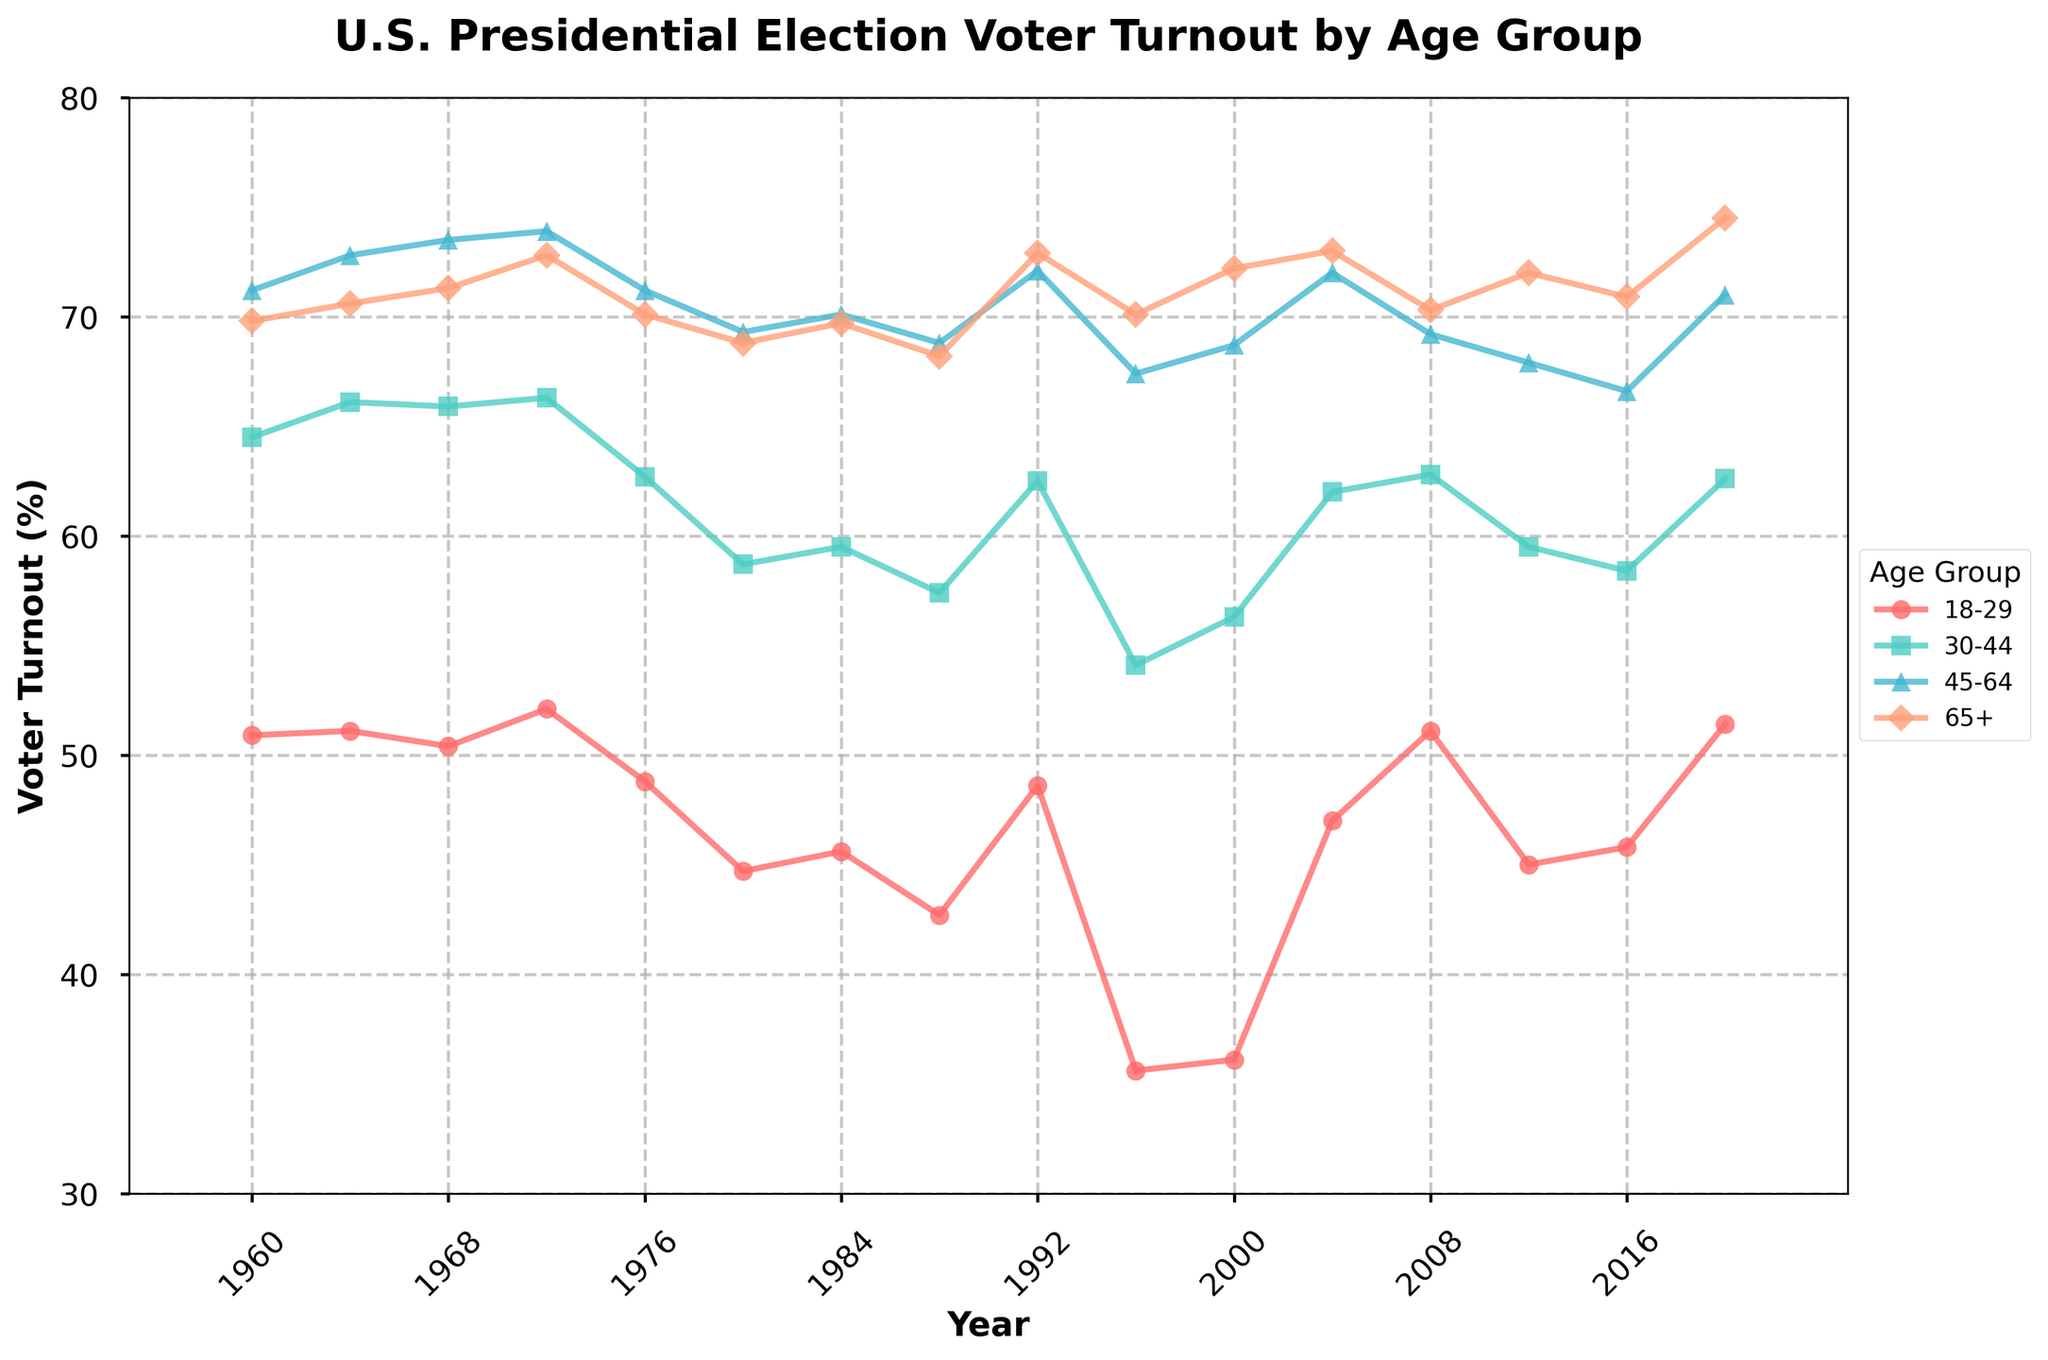What is the overall trend in voter turnout among the 18-29 age group from 1960 to 2020? The 18-29 age group shows fluctuations in voter turnout over the years. Starting at 50.9% in 1960, it remains relatively steady until the mid-1970s, then sees a decline until the mid-1990s, and begins to rise again from 2000 onwards, peaking at 51.4% in 2020.
Answer: Fluctuating, with a peak at 2020 Which age group had the highest voter turnout in the 1972 election? By examining the peaks for the year 1972 in the figure, the 45-64 age group has the highest voter turnout at 73.9%.
Answer: 45-64 age group How do the voter turnout rates in 1964 for the 30-44 and 45-64 age groups compare? In 1964, voter turnout for the 30-44 age group was 66.1%, while for the 45-64 age group, it was 72.8%. The 45-64 age group had a higher turnout rate.
Answer: 45-64 age group had higher turnout What is the difference between the voter turnout rates of the 30-44 and 65+ age groups in 2020? In 2020, the voter turnout for the 30-44 age group was 62.6%, and for the 65+ age group, it was 74.5%. The difference is 74.5% - 62.6% = 11.9%.
Answer: 11.9% Which age group experienced the largest drop in voter turnout between 1992 and 1996? Comparing the rates between 1992 and 1996, the 18-29 age group dropped from 48.6% to 35.6%, a decrease of 13%. This is the largest drop among the age groups.
Answer: 18-29 age group What is the average voter turnout rate for the 45-64 age group across all the years provided? The average voter turnout rate for the 45-64 age group is calculated by summing its percentages and dividing by the number of years: (71.2 + 72.8 + 73.5 + 73.9 + 71.2 + 69.3 + 70.1 + 68.8 + 72.1 + 67.4 + 68.7 + 72.0 + 69.2 + 67.9 + 66.6 + 71.0) / 16 = 70.42%.
Answer: 70.42% In what year did the 65+ age group first surpass a 70% voter turnout rate? Looking at the line for the 65+ age group on the chart, the first year it surpasses a 70% voter turnout rate is in 1964 with 70.6%.
Answer: 1964 Considering the visual representation in the plot, which age group used a triangular marker, and how did their voter turnout change from 1968 to 1976? The age group with a triangular marker is the 45-64 age group. From 1968 to 1976, their voter turnout decreased from 73.5% to 71.2%.
Answer: 45-64 age group; decreased by 2.3% 